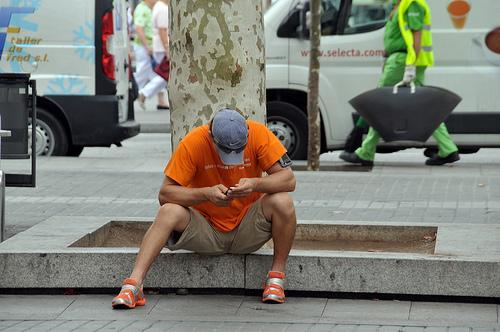What device is the one most probably attached to the man's arm? phone 